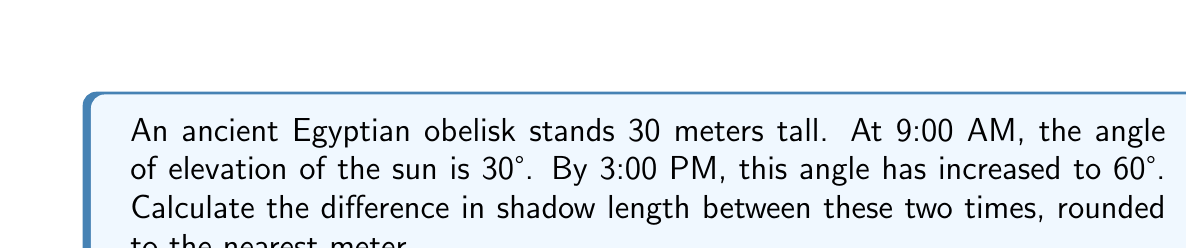Solve this math problem. Let's approach this step-by-step using trigonometry:

1) First, let's recall the tangent function:
   $\tan \theta = \frac{\text{opposite}}{\text{adjacent}} = \frac{\text{height of obelisk}}{\text{length of shadow}}$

2) At 9:00 AM:
   $\tan 30° = \frac{30}{\text{shadow length at 9 AM}}$
   $\frac{1}{\sqrt{3}} = \frac{30}{\text{shadow length at 9 AM}}$
   Shadow length at 9 AM $= 30 \sqrt{3} \approx 51.96$ meters

3) At 3:00 PM:
   $\tan 60° = \frac{30}{\text{shadow length at 3 PM}}$
   $\sqrt{3} = \frac{30}{\text{shadow length at 3 PM}}$
   Shadow length at 3 PM $= \frac{30}{\sqrt{3}} \approx 17.32$ meters

4) Difference in shadow length:
   $51.96 - 17.32 = 34.64$ meters

5) Rounding to the nearest meter:
   $34.64 \approx 35$ meters

[asy]
import geometry;

size(200);
draw((0,0)--(100,0), arrow=Arrow);
draw((0,0)--(0,60), arrow=Arrow);
draw((0,0)--(86.6,50), arrow=Arrow);
draw((0,0)--(50,86.6), arrow=Arrow);
draw((0,0)--(100,57.7));
draw((86.6,0)--(86.6,50));
draw((50,0)--(50,86.6));

label("9 AM", (93,25), E);
label("3 PM", (55,80), N);
label("30°", (10,10), NE);
label("60°", (5,40), NW);
label("Obelisk", (0,30), W);
</asy>
Answer: 35 meters 